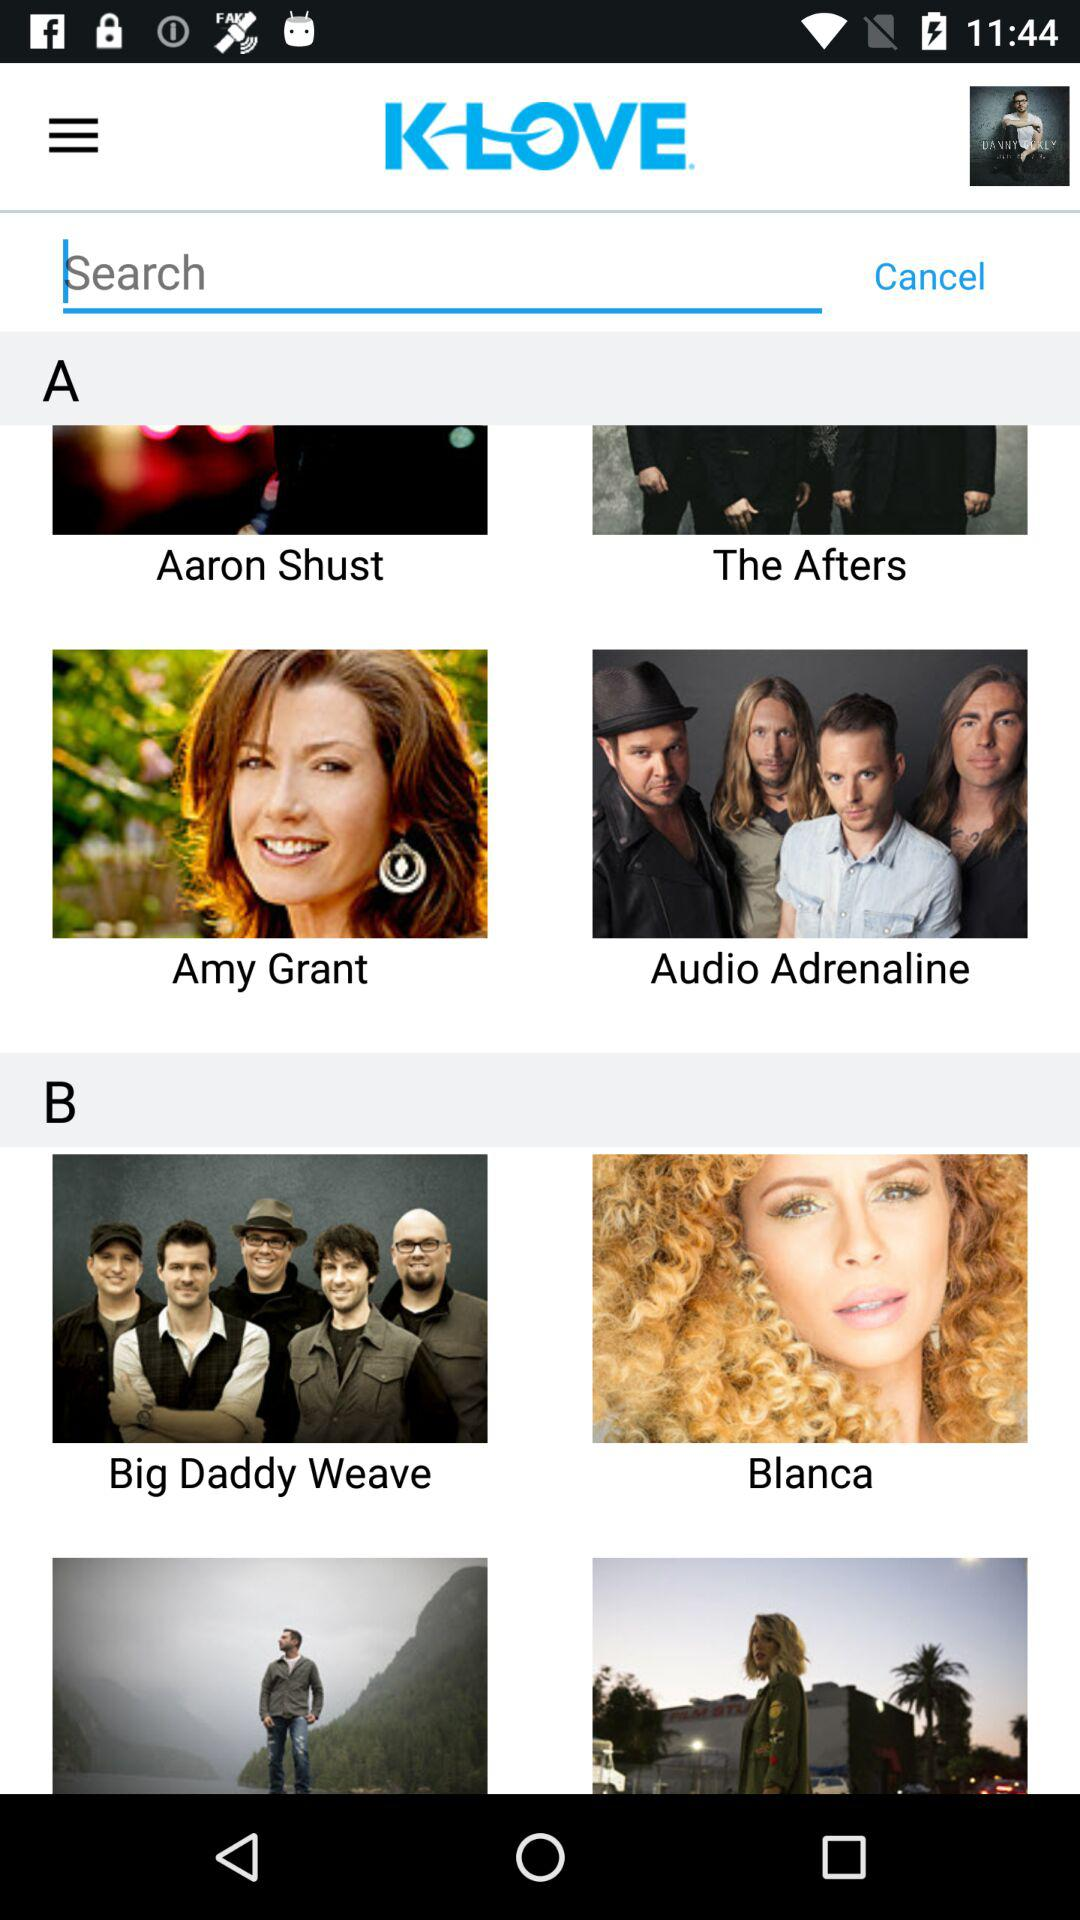How many people like "KLOVE"?
When the provided information is insufficient, respond with <no answer>. <no answer> 